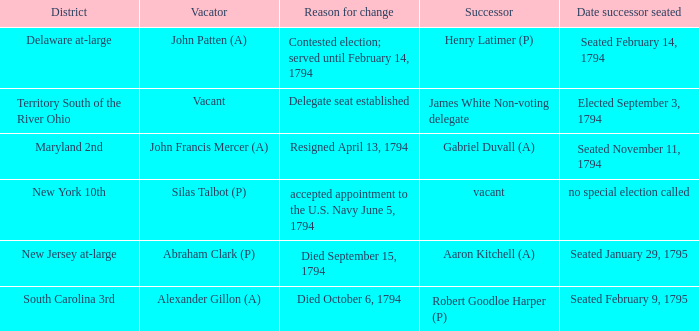Name the date successor seated for contested election; served until february 14, 1794 Seated February 14, 1794. 